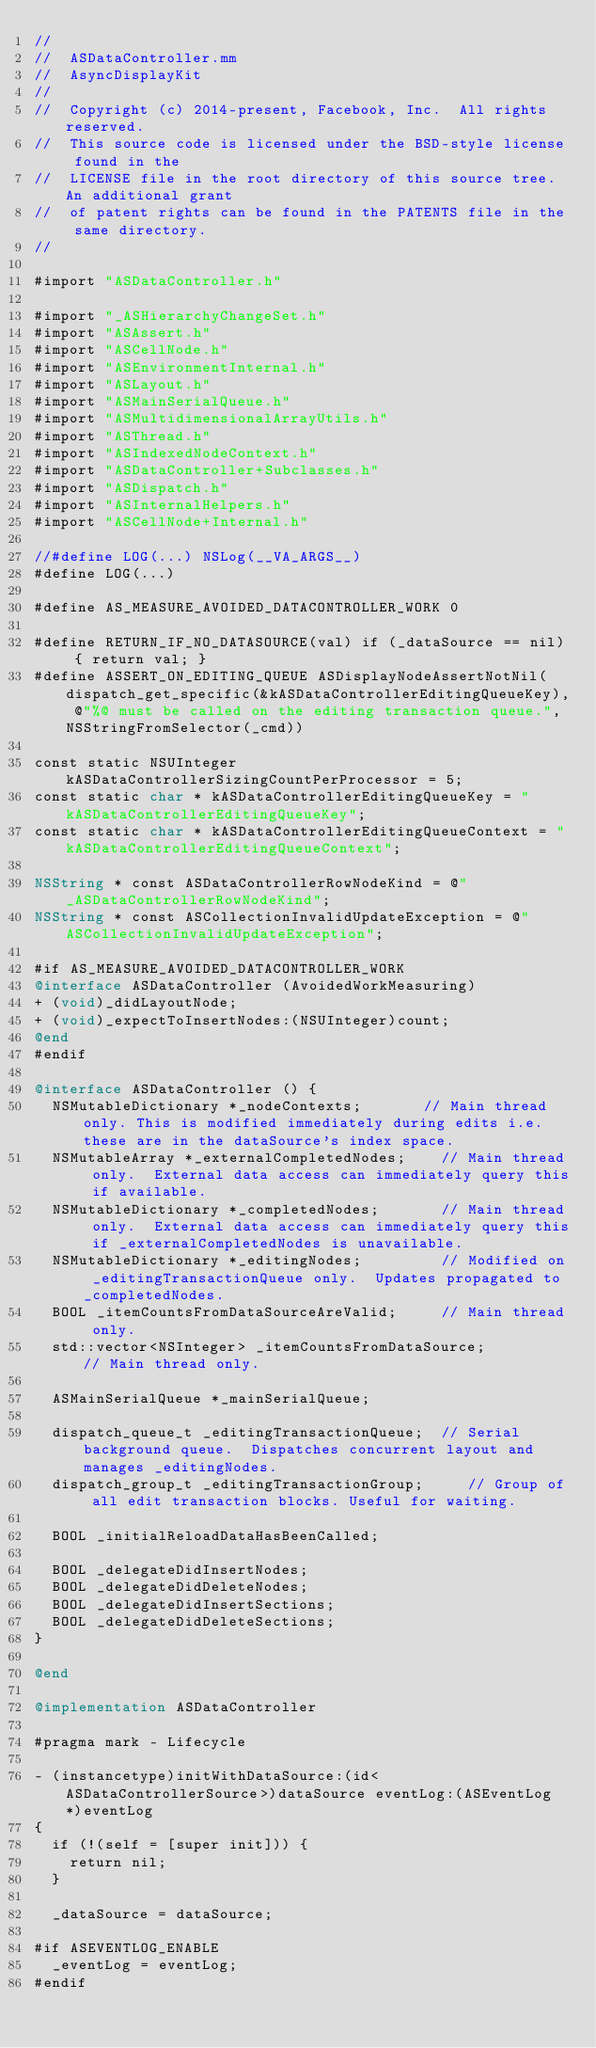<code> <loc_0><loc_0><loc_500><loc_500><_ObjectiveC_>//
//  ASDataController.mm
//  AsyncDisplayKit
//
//  Copyright (c) 2014-present, Facebook, Inc.  All rights reserved.
//  This source code is licensed under the BSD-style license found in the
//  LICENSE file in the root directory of this source tree. An additional grant
//  of patent rights can be found in the PATENTS file in the same directory.
//

#import "ASDataController.h"

#import "_ASHierarchyChangeSet.h"
#import "ASAssert.h"
#import "ASCellNode.h"
#import "ASEnvironmentInternal.h"
#import "ASLayout.h"
#import "ASMainSerialQueue.h"
#import "ASMultidimensionalArrayUtils.h"
#import "ASThread.h"
#import "ASIndexedNodeContext.h"
#import "ASDataController+Subclasses.h"
#import "ASDispatch.h"
#import "ASInternalHelpers.h"
#import "ASCellNode+Internal.h"

//#define LOG(...) NSLog(__VA_ARGS__)
#define LOG(...)

#define AS_MEASURE_AVOIDED_DATACONTROLLER_WORK 0

#define RETURN_IF_NO_DATASOURCE(val) if (_dataSource == nil) { return val; }
#define ASSERT_ON_EDITING_QUEUE ASDisplayNodeAssertNotNil(dispatch_get_specific(&kASDataControllerEditingQueueKey), @"%@ must be called on the editing transaction queue.", NSStringFromSelector(_cmd))

const static NSUInteger kASDataControllerSizingCountPerProcessor = 5;
const static char * kASDataControllerEditingQueueKey = "kASDataControllerEditingQueueKey";
const static char * kASDataControllerEditingQueueContext = "kASDataControllerEditingQueueContext";

NSString * const ASDataControllerRowNodeKind = @"_ASDataControllerRowNodeKind";
NSString * const ASCollectionInvalidUpdateException = @"ASCollectionInvalidUpdateException";

#if AS_MEASURE_AVOIDED_DATACONTROLLER_WORK
@interface ASDataController (AvoidedWorkMeasuring)
+ (void)_didLayoutNode;
+ (void)_expectToInsertNodes:(NSUInteger)count;
@end
#endif

@interface ASDataController () {
  NSMutableDictionary *_nodeContexts;       // Main thread only. This is modified immediately during edits i.e. these are in the dataSource's index space.
  NSMutableArray *_externalCompletedNodes;    // Main thread only.  External data access can immediately query this if available.
  NSMutableDictionary *_completedNodes;       // Main thread only.  External data access can immediately query this if _externalCompletedNodes is unavailable.
  NSMutableDictionary *_editingNodes;         // Modified on _editingTransactionQueue only.  Updates propagated to _completedNodes.
  BOOL _itemCountsFromDataSourceAreValid;     // Main thread only.
  std::vector<NSInteger> _itemCountsFromDataSource;         // Main thread only.
  
  ASMainSerialQueue *_mainSerialQueue;

  dispatch_queue_t _editingTransactionQueue;  // Serial background queue.  Dispatches concurrent layout and manages _editingNodes.
  dispatch_group_t _editingTransactionGroup;     // Group of all edit transaction blocks. Useful for waiting.
  
  BOOL _initialReloadDataHasBeenCalled;

  BOOL _delegateDidInsertNodes;
  BOOL _delegateDidDeleteNodes;
  BOOL _delegateDidInsertSections;
  BOOL _delegateDidDeleteSections;
}

@end

@implementation ASDataController

#pragma mark - Lifecycle

- (instancetype)initWithDataSource:(id<ASDataControllerSource>)dataSource eventLog:(ASEventLog *)eventLog
{
  if (!(self = [super init])) {
    return nil;
  }
  
  _dataSource = dataSource;
  
#if ASEVENTLOG_ENABLE
  _eventLog = eventLog;
#endif
  </code> 